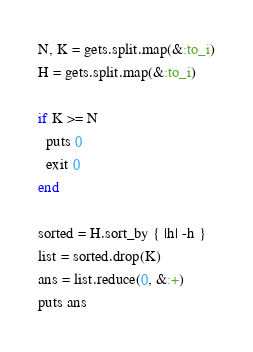<code> <loc_0><loc_0><loc_500><loc_500><_Ruby_>N, K = gets.split.map(&:to_i)
H = gets.split.map(&:to_i)

if K >= N
  puts 0
  exit 0
end

sorted = H.sort_by { |h| -h }
list = sorted.drop(K)
ans = list.reduce(0, &:+)
puts ans</code> 